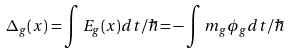<formula> <loc_0><loc_0><loc_500><loc_500>\Delta _ { g } ( x ) = \int E _ { g } ( x ) d t / \hbar { = } - \int m _ { g } \phi _ { g } d t / \hbar</formula> 